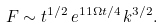Convert formula to latex. <formula><loc_0><loc_0><loc_500><loc_500>F \sim t ^ { 1 / 2 } \, e ^ { 1 1 \Omega t / 4 } \, k ^ { 3 / 2 } .</formula> 